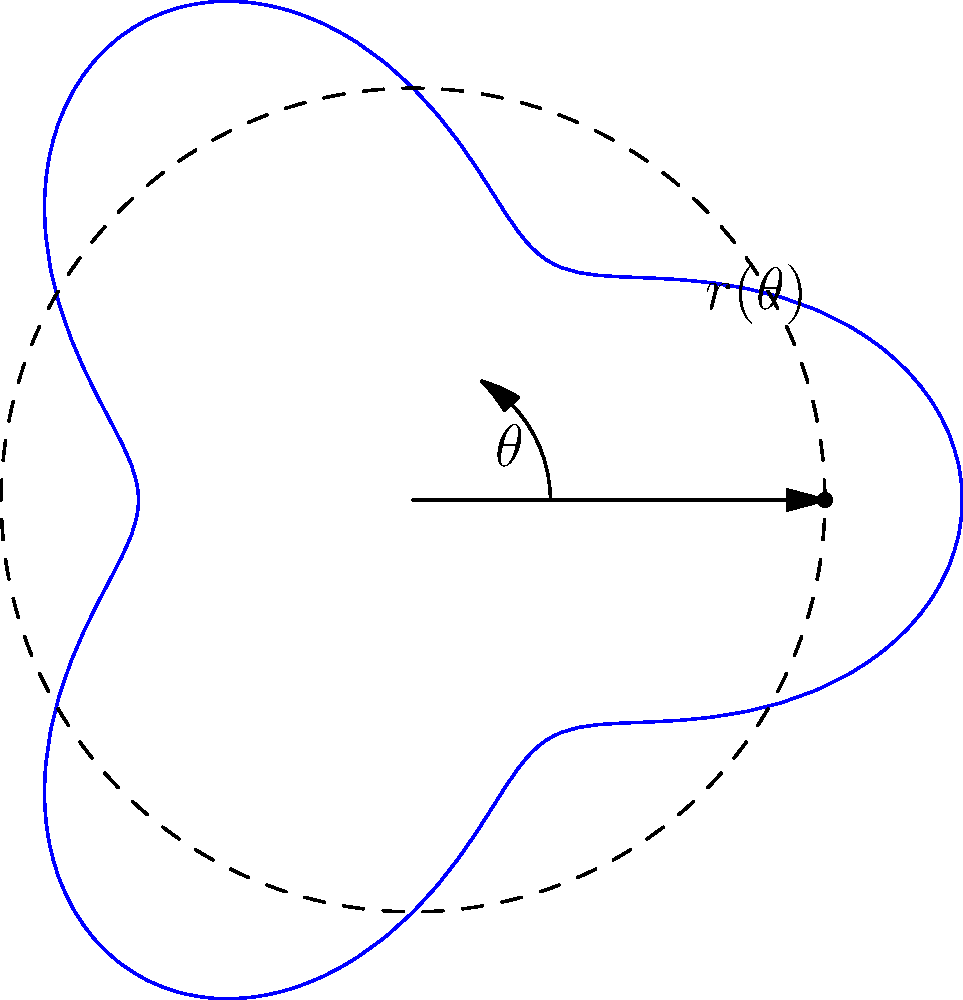In competitive taekwondo, a spinning kick's effectiveness is often determined by the angle of rotation. Consider a model where the distance $r$ from the center of rotation to the striking point of your foot is given by the polar equation $r(\theta) = 3 + \cos(3\theta)$, where $\theta$ is in radians. At what angle $\theta$ (in degrees) does your foot reach its maximum distance from the center of rotation, potentially delivering the most powerful kick? To find the maximum distance, we need to follow these steps:

1) The distance $r$ is maximum when $\cos(3\theta)$ is at its maximum value of 1.

2) $\cos(3\theta) = 1$ when $3\theta = 0, 2\pi, 4\pi, ...$

3) Solving for the smallest positive $\theta$:
   $3\theta = 0$
   $\theta = 0$

4) However, we need to consider the full range of the function over one period:
   $0 \leq \theta < \frac{2\pi}{3}$

5) Within this range, the maximum occurs at:
   $\theta = 0, \frac{2\pi}{9}, \frac{4\pi}{9}$

6) Converting the first non-zero angle to degrees:
   $\frac{2\pi}{9} \text{ radians} = \frac{2\pi}{9} \cdot \frac{180^{\circ}}{\pi} = 40^{\circ}$

Therefore, the first non-zero angle at which the foot reaches its maximum distance is 40°.
Answer: 40° 